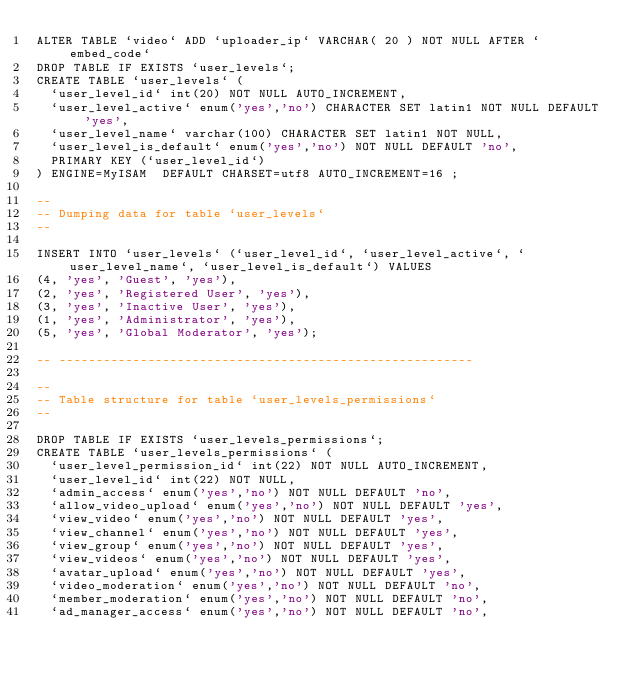Convert code to text. <code><loc_0><loc_0><loc_500><loc_500><_SQL_>ALTER TABLE `video` ADD `uploader_ip` VARCHAR( 20 ) NOT NULL AFTER `embed_code`
DROP TABLE IF EXISTS `user_levels`;
CREATE TABLE `user_levels` (
  `user_level_id` int(20) NOT NULL AUTO_INCREMENT,
  `user_level_active` enum('yes','no') CHARACTER SET latin1 NOT NULL DEFAULT 'yes',
  `user_level_name` varchar(100) CHARACTER SET latin1 NOT NULL,
  `user_level_is_default` enum('yes','no') NOT NULL DEFAULT 'no',
  PRIMARY KEY (`user_level_id`)
) ENGINE=MyISAM  DEFAULT CHARSET=utf8 AUTO_INCREMENT=16 ;

--
-- Dumping data for table `user_levels`
--

INSERT INTO `user_levels` (`user_level_id`, `user_level_active`, `user_level_name`, `user_level_is_default`) VALUES
(4, 'yes', 'Guest', 'yes'),
(2, 'yes', 'Registered User', 'yes'),
(3, 'yes', 'Inactive User', 'yes'),
(1, 'yes', 'Administrator', 'yes'),
(5, 'yes', 'Global Moderator', 'yes');

-- --------------------------------------------------------

--
-- Table structure for table `user_levels_permissions`
--

DROP TABLE IF EXISTS `user_levels_permissions`;
CREATE TABLE `user_levels_permissions` (
  `user_level_permission_id` int(22) NOT NULL AUTO_INCREMENT,
  `user_level_id` int(22) NOT NULL,
  `admin_access` enum('yes','no') NOT NULL DEFAULT 'no',
  `allow_video_upload` enum('yes','no') NOT NULL DEFAULT 'yes',
  `view_video` enum('yes','no') NOT NULL DEFAULT 'yes',
  `view_channel` enum('yes','no') NOT NULL DEFAULT 'yes',
  `view_group` enum('yes','no') NOT NULL DEFAULT 'yes',
  `view_videos` enum('yes','no') NOT NULL DEFAULT 'yes',
  `avatar_upload` enum('yes','no') NOT NULL DEFAULT 'yes',
  `video_moderation` enum('yes','no') NOT NULL DEFAULT 'no',
  `member_moderation` enum('yes','no') NOT NULL DEFAULT 'no',
  `ad_manager_access` enum('yes','no') NOT NULL DEFAULT 'no',</code> 